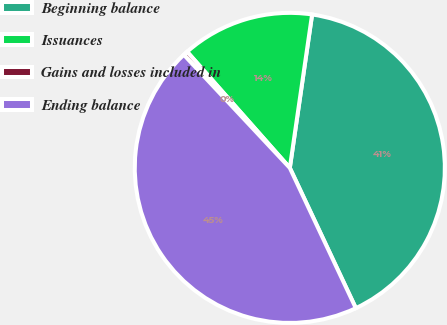<chart> <loc_0><loc_0><loc_500><loc_500><pie_chart><fcel>Beginning balance<fcel>Issuances<fcel>Gains and losses included in<fcel>Ending balance<nl><fcel>40.7%<fcel>13.82%<fcel>0.46%<fcel>45.02%<nl></chart> 